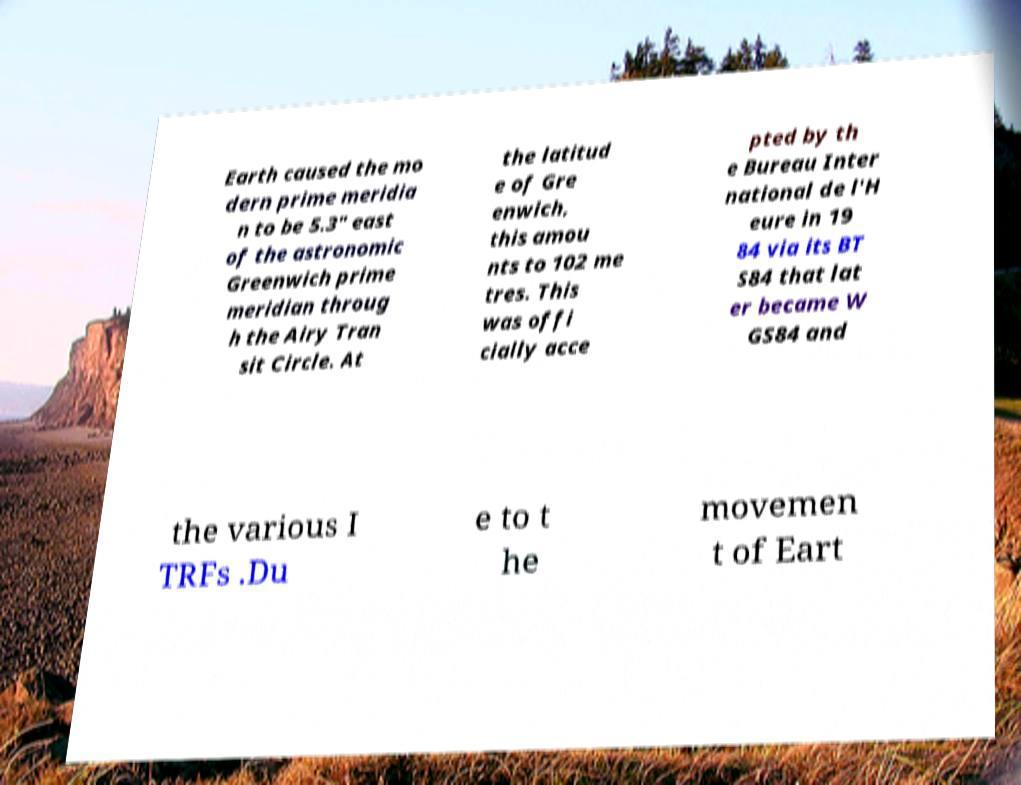What messages or text are displayed in this image? I need them in a readable, typed format. Earth caused the mo dern prime meridia n to be 5.3″ east of the astronomic Greenwich prime meridian throug h the Airy Tran sit Circle. At the latitud e of Gre enwich, this amou nts to 102 me tres. This was offi cially acce pted by th e Bureau Inter national de l'H eure in 19 84 via its BT S84 that lat er became W GS84 and the various I TRFs .Du e to t he movemen t of Eart 